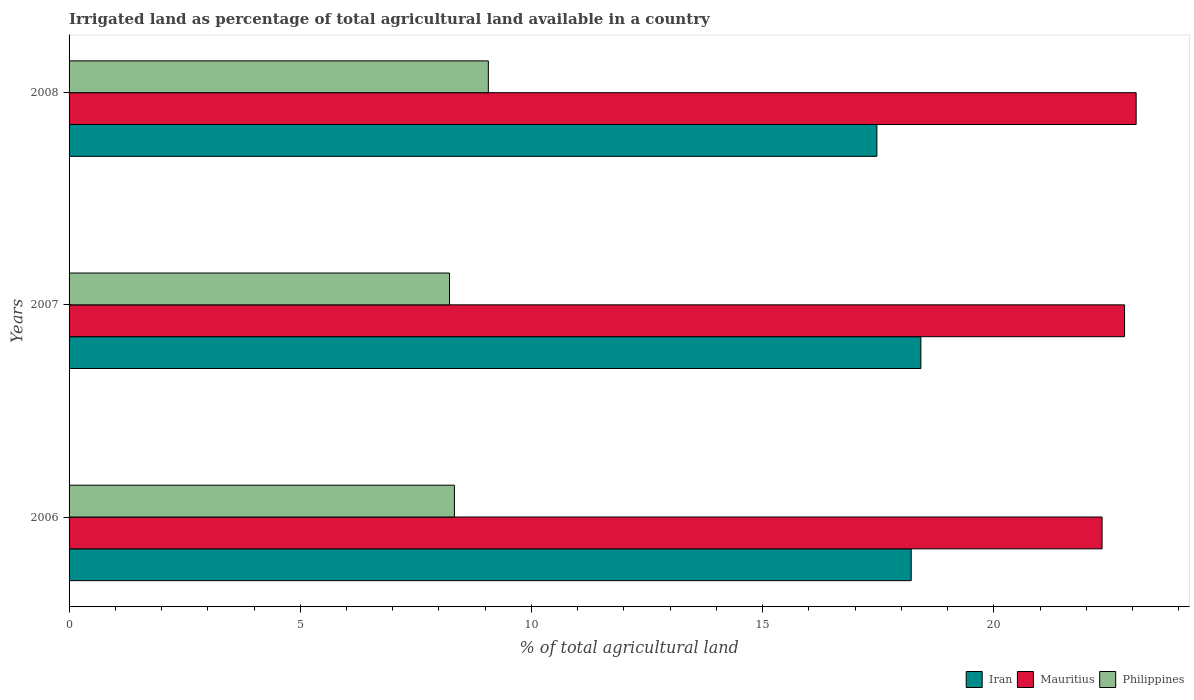How many groups of bars are there?
Your response must be concise. 3. Are the number of bars per tick equal to the number of legend labels?
Provide a short and direct response. Yes. What is the label of the 2nd group of bars from the top?
Offer a terse response. 2007. What is the percentage of irrigated land in Mauritius in 2008?
Offer a terse response. 23.08. Across all years, what is the maximum percentage of irrigated land in Mauritius?
Your answer should be very brief. 23.08. Across all years, what is the minimum percentage of irrigated land in Philippines?
Offer a very short reply. 8.23. In which year was the percentage of irrigated land in Philippines maximum?
Your response must be concise. 2008. In which year was the percentage of irrigated land in Philippines minimum?
Provide a succinct answer. 2007. What is the total percentage of irrigated land in Philippines in the graph?
Your response must be concise. 25.63. What is the difference between the percentage of irrigated land in Philippines in 2006 and that in 2007?
Your response must be concise. 0.11. What is the difference between the percentage of irrigated land in Mauritius in 2006 and the percentage of irrigated land in Philippines in 2008?
Your answer should be very brief. 13.27. What is the average percentage of irrigated land in Philippines per year?
Make the answer very short. 8.54. In the year 2007, what is the difference between the percentage of irrigated land in Philippines and percentage of irrigated land in Mauritius?
Offer a very short reply. -14.6. What is the ratio of the percentage of irrigated land in Iran in 2006 to that in 2008?
Give a very brief answer. 1.04. Is the percentage of irrigated land in Iran in 2006 less than that in 2008?
Make the answer very short. No. Is the difference between the percentage of irrigated land in Philippines in 2006 and 2008 greater than the difference between the percentage of irrigated land in Mauritius in 2006 and 2008?
Your response must be concise. Yes. What is the difference between the highest and the second highest percentage of irrigated land in Iran?
Keep it short and to the point. 0.21. What is the difference between the highest and the lowest percentage of irrigated land in Philippines?
Ensure brevity in your answer.  0.84. In how many years, is the percentage of irrigated land in Philippines greater than the average percentage of irrigated land in Philippines taken over all years?
Your response must be concise. 1. What does the 1st bar from the top in 2006 represents?
Give a very brief answer. Philippines. What does the 1st bar from the bottom in 2008 represents?
Make the answer very short. Iran. Is it the case that in every year, the sum of the percentage of irrigated land in Iran and percentage of irrigated land in Philippines is greater than the percentage of irrigated land in Mauritius?
Give a very brief answer. Yes. Are all the bars in the graph horizontal?
Give a very brief answer. Yes. What is the difference between two consecutive major ticks on the X-axis?
Provide a short and direct response. 5. Are the values on the major ticks of X-axis written in scientific E-notation?
Your answer should be compact. No. Does the graph contain any zero values?
Offer a terse response. No. Does the graph contain grids?
Your response must be concise. No. Where does the legend appear in the graph?
Offer a very short reply. Bottom right. How many legend labels are there?
Give a very brief answer. 3. What is the title of the graph?
Your answer should be compact. Irrigated land as percentage of total agricultural land available in a country. Does "Saudi Arabia" appear as one of the legend labels in the graph?
Provide a short and direct response. No. What is the label or title of the X-axis?
Your answer should be compact. % of total agricultural land. What is the % of total agricultural land in Iran in 2006?
Your answer should be very brief. 18.21. What is the % of total agricultural land in Mauritius in 2006?
Your answer should be very brief. 22.34. What is the % of total agricultural land of Philippines in 2006?
Offer a terse response. 8.33. What is the % of total agricultural land in Iran in 2007?
Offer a very short reply. 18.42. What is the % of total agricultural land in Mauritius in 2007?
Ensure brevity in your answer.  22.83. What is the % of total agricultural land in Philippines in 2007?
Ensure brevity in your answer.  8.23. What is the % of total agricultural land of Iran in 2008?
Provide a succinct answer. 17.47. What is the % of total agricultural land in Mauritius in 2008?
Keep it short and to the point. 23.08. What is the % of total agricultural land of Philippines in 2008?
Keep it short and to the point. 9.07. Across all years, what is the maximum % of total agricultural land in Iran?
Offer a very short reply. 18.42. Across all years, what is the maximum % of total agricultural land of Mauritius?
Your response must be concise. 23.08. Across all years, what is the maximum % of total agricultural land in Philippines?
Offer a terse response. 9.07. Across all years, what is the minimum % of total agricultural land in Iran?
Make the answer very short. 17.47. Across all years, what is the minimum % of total agricultural land of Mauritius?
Offer a very short reply. 22.34. Across all years, what is the minimum % of total agricultural land of Philippines?
Give a very brief answer. 8.23. What is the total % of total agricultural land in Iran in the graph?
Keep it short and to the point. 54.1. What is the total % of total agricultural land of Mauritius in the graph?
Your answer should be compact. 68.24. What is the total % of total agricultural land of Philippines in the graph?
Keep it short and to the point. 25.63. What is the difference between the % of total agricultural land in Iran in 2006 and that in 2007?
Provide a succinct answer. -0.21. What is the difference between the % of total agricultural land in Mauritius in 2006 and that in 2007?
Your answer should be very brief. -0.49. What is the difference between the % of total agricultural land in Philippines in 2006 and that in 2007?
Keep it short and to the point. 0.11. What is the difference between the % of total agricultural land in Iran in 2006 and that in 2008?
Offer a very short reply. 0.74. What is the difference between the % of total agricultural land of Mauritius in 2006 and that in 2008?
Ensure brevity in your answer.  -0.74. What is the difference between the % of total agricultural land in Philippines in 2006 and that in 2008?
Make the answer very short. -0.73. What is the difference between the % of total agricultural land in Iran in 2007 and that in 2008?
Give a very brief answer. 0.95. What is the difference between the % of total agricultural land in Mauritius in 2007 and that in 2008?
Provide a short and direct response. -0.25. What is the difference between the % of total agricultural land in Philippines in 2007 and that in 2008?
Ensure brevity in your answer.  -0.84. What is the difference between the % of total agricultural land of Iran in 2006 and the % of total agricultural land of Mauritius in 2007?
Give a very brief answer. -4.61. What is the difference between the % of total agricultural land of Iran in 2006 and the % of total agricultural land of Philippines in 2007?
Provide a succinct answer. 9.99. What is the difference between the % of total agricultural land in Mauritius in 2006 and the % of total agricultural land in Philippines in 2007?
Provide a succinct answer. 14.11. What is the difference between the % of total agricultural land in Iran in 2006 and the % of total agricultural land in Mauritius in 2008?
Offer a very short reply. -4.86. What is the difference between the % of total agricultural land of Iran in 2006 and the % of total agricultural land of Philippines in 2008?
Provide a succinct answer. 9.14. What is the difference between the % of total agricultural land in Mauritius in 2006 and the % of total agricultural land in Philippines in 2008?
Offer a terse response. 13.27. What is the difference between the % of total agricultural land of Iran in 2007 and the % of total agricultural land of Mauritius in 2008?
Offer a terse response. -4.65. What is the difference between the % of total agricultural land in Iran in 2007 and the % of total agricultural land in Philippines in 2008?
Keep it short and to the point. 9.35. What is the difference between the % of total agricultural land of Mauritius in 2007 and the % of total agricultural land of Philippines in 2008?
Your response must be concise. 13.76. What is the average % of total agricultural land in Iran per year?
Provide a succinct answer. 18.03. What is the average % of total agricultural land in Mauritius per year?
Your answer should be very brief. 22.75. What is the average % of total agricultural land in Philippines per year?
Give a very brief answer. 8.54. In the year 2006, what is the difference between the % of total agricultural land of Iran and % of total agricultural land of Mauritius?
Ensure brevity in your answer.  -4.13. In the year 2006, what is the difference between the % of total agricultural land in Iran and % of total agricultural land in Philippines?
Offer a terse response. 9.88. In the year 2006, what is the difference between the % of total agricultural land in Mauritius and % of total agricultural land in Philippines?
Your answer should be compact. 14.01. In the year 2007, what is the difference between the % of total agricultural land of Iran and % of total agricultural land of Mauritius?
Keep it short and to the point. -4.4. In the year 2007, what is the difference between the % of total agricultural land in Iran and % of total agricultural land in Philippines?
Your response must be concise. 10.19. In the year 2007, what is the difference between the % of total agricultural land of Mauritius and % of total agricultural land of Philippines?
Your response must be concise. 14.6. In the year 2008, what is the difference between the % of total agricultural land of Iran and % of total agricultural land of Mauritius?
Provide a succinct answer. -5.61. In the year 2008, what is the difference between the % of total agricultural land in Iran and % of total agricultural land in Philippines?
Make the answer very short. 8.4. In the year 2008, what is the difference between the % of total agricultural land in Mauritius and % of total agricultural land in Philippines?
Provide a succinct answer. 14.01. What is the ratio of the % of total agricultural land in Mauritius in 2006 to that in 2007?
Give a very brief answer. 0.98. What is the ratio of the % of total agricultural land of Philippines in 2006 to that in 2007?
Ensure brevity in your answer.  1.01. What is the ratio of the % of total agricultural land in Iran in 2006 to that in 2008?
Provide a short and direct response. 1.04. What is the ratio of the % of total agricultural land in Mauritius in 2006 to that in 2008?
Your answer should be very brief. 0.97. What is the ratio of the % of total agricultural land of Philippines in 2006 to that in 2008?
Your response must be concise. 0.92. What is the ratio of the % of total agricultural land of Iran in 2007 to that in 2008?
Your answer should be very brief. 1.05. What is the ratio of the % of total agricultural land in Mauritius in 2007 to that in 2008?
Offer a terse response. 0.99. What is the ratio of the % of total agricultural land in Philippines in 2007 to that in 2008?
Your answer should be very brief. 0.91. What is the difference between the highest and the second highest % of total agricultural land in Iran?
Ensure brevity in your answer.  0.21. What is the difference between the highest and the second highest % of total agricultural land of Mauritius?
Provide a succinct answer. 0.25. What is the difference between the highest and the second highest % of total agricultural land in Philippines?
Your response must be concise. 0.73. What is the difference between the highest and the lowest % of total agricultural land in Iran?
Your answer should be very brief. 0.95. What is the difference between the highest and the lowest % of total agricultural land in Mauritius?
Provide a short and direct response. 0.74. What is the difference between the highest and the lowest % of total agricultural land in Philippines?
Keep it short and to the point. 0.84. 